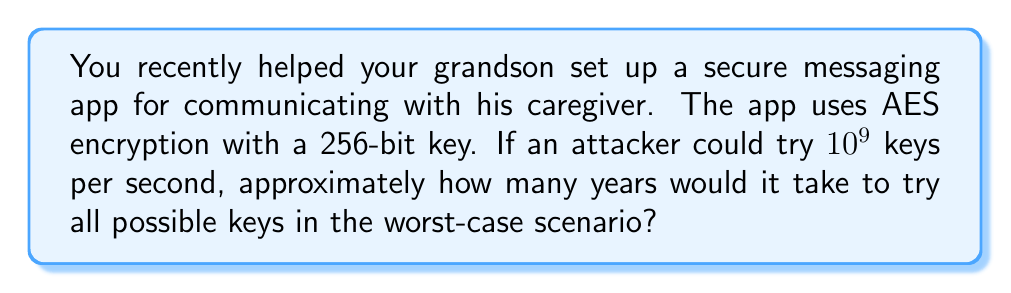Show me your answer to this math problem. Let's approach this step-by-step:

1) First, we need to calculate the total number of possible keys:
   For a 256-bit key, there are $2^{256}$ possible combinations.

2) Now, let's convert the attacker's speed to keys per year:
   Keys per year = $10^9 \times 60 \times 60 \times 24 \times 365.25$
                 = $31,557,600,000,000$ keys/year

3) To find the time needed, we divide the total number of keys by the keys per year:
   Time (in years) = $\frac{2^{256}}{31,557,600,000,000}$

4) Let's simplify this:
   $\frac{2^{256}}{31,557,600,000,000} = \frac{2^{256}}{3.15576 \times 10^{13}}$

5) Using a calculator or computer, we can evaluate this to approximately:
   $3.67 \times 10^{63}$ years

This is an enormously large number, far exceeding the age of the universe (which is about $13.8 \times 10^9$ years).
Answer: $3.67 \times 10^{63}$ years 